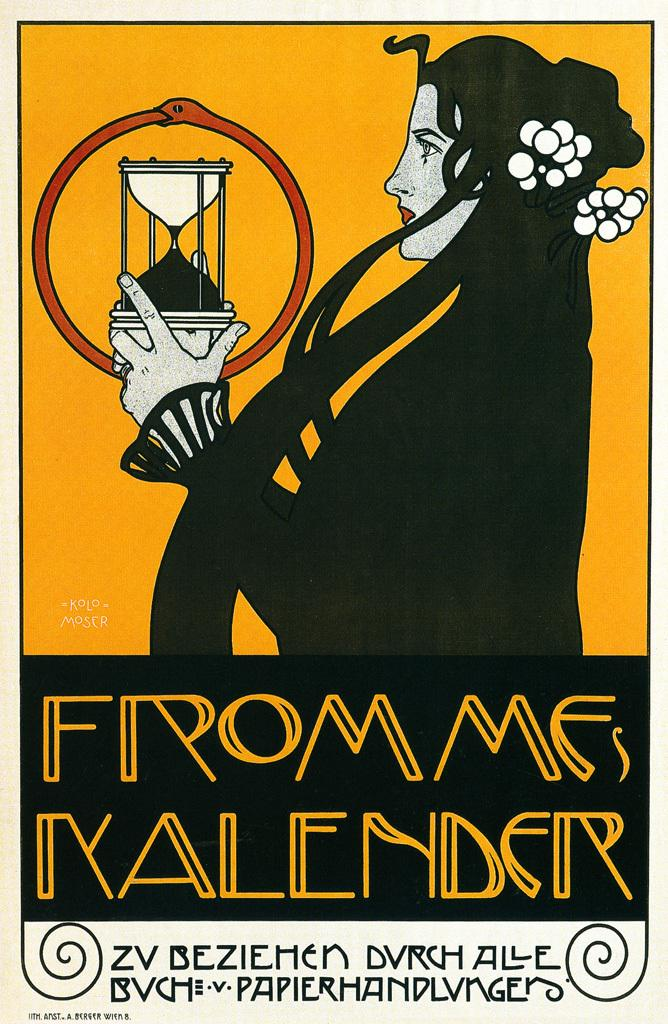<image>
Present a compact description of the photo's key features. White flowers ore pinned in a woman's hair that is on a advertisement poster for Frommes Kalender. 